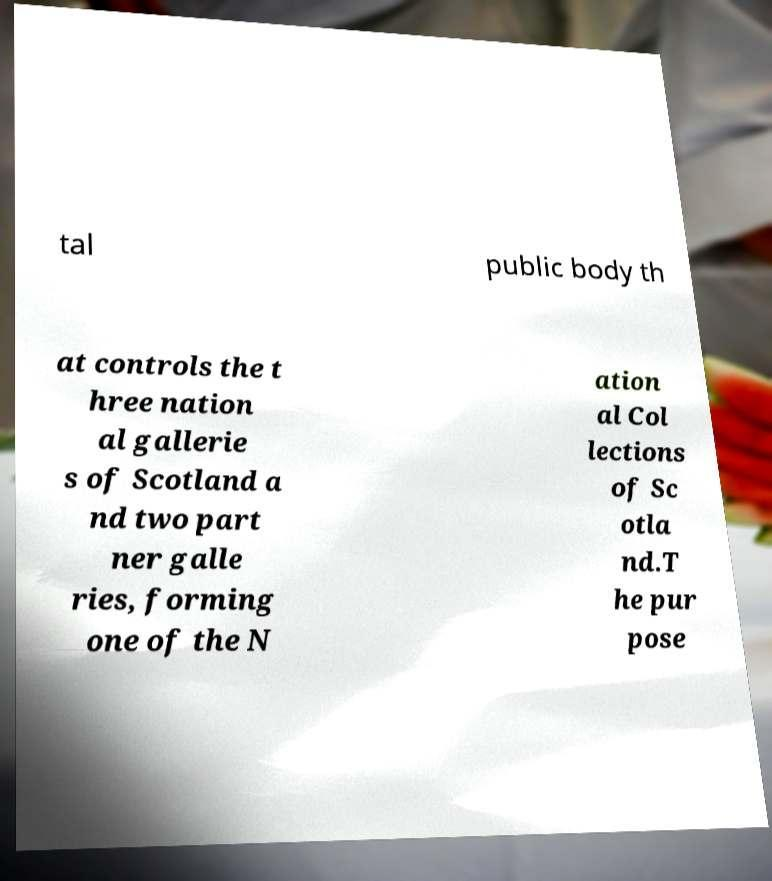Could you extract and type out the text from this image? tal public body th at controls the t hree nation al gallerie s of Scotland a nd two part ner galle ries, forming one of the N ation al Col lections of Sc otla nd.T he pur pose 